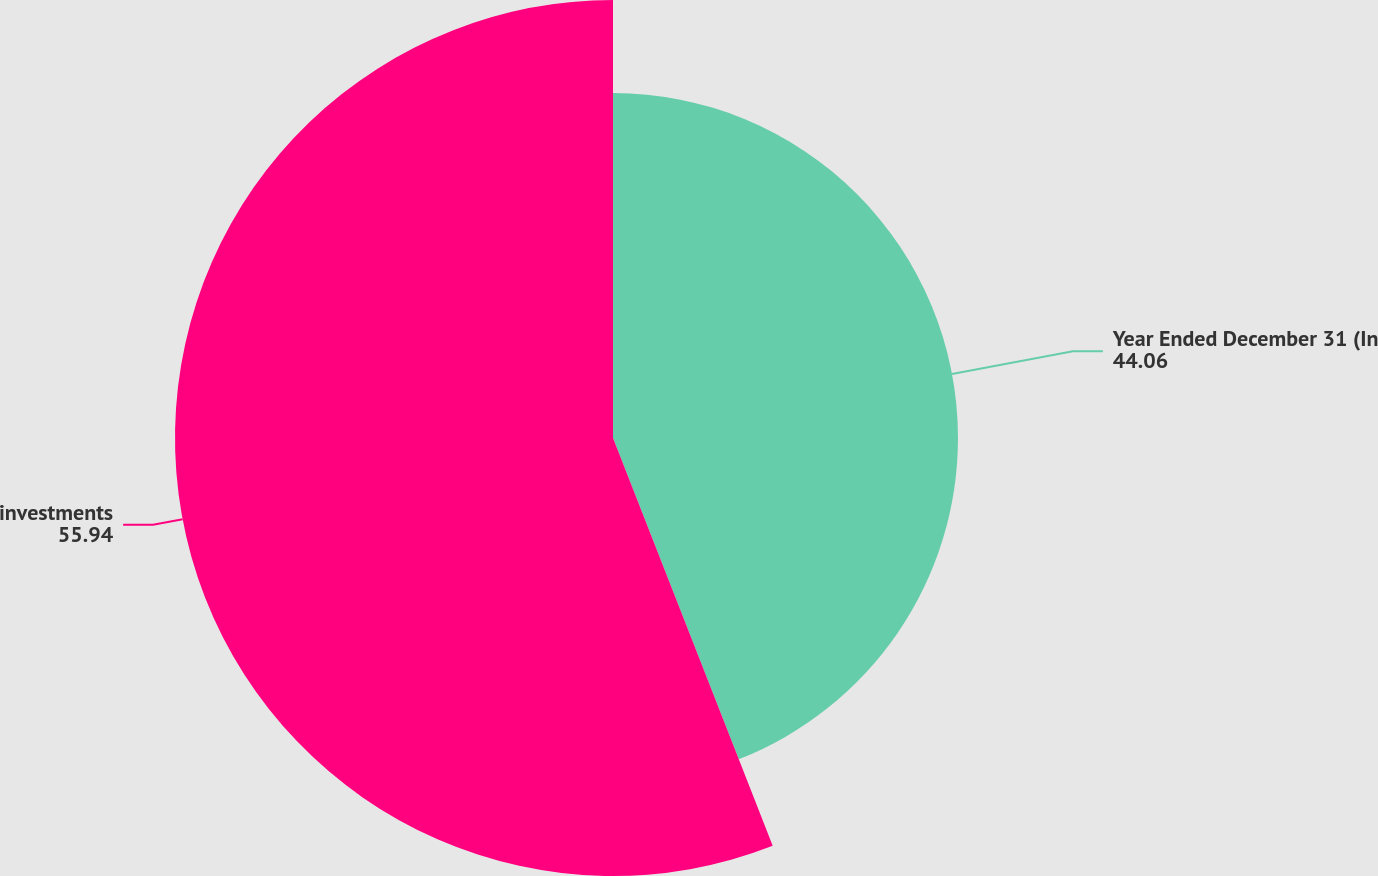Convert chart. <chart><loc_0><loc_0><loc_500><loc_500><pie_chart><fcel>Year Ended December 31 (In<fcel>investments<nl><fcel>44.06%<fcel>55.94%<nl></chart> 